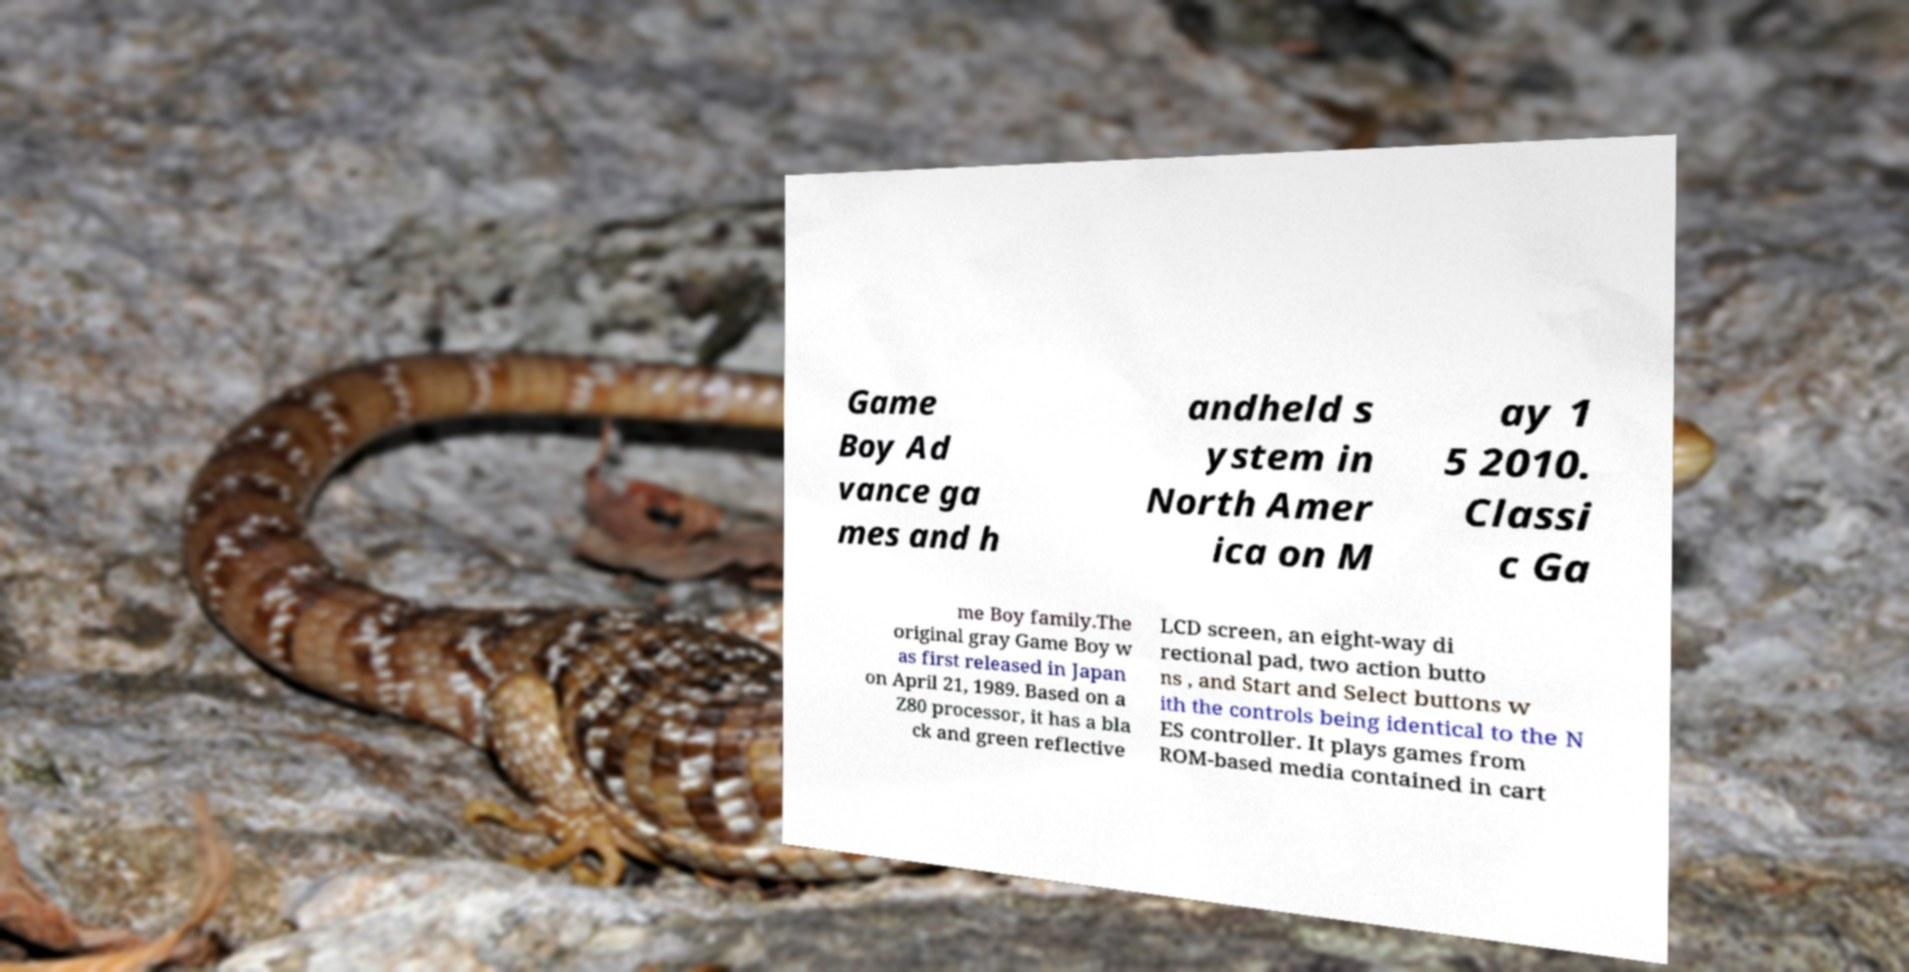For documentation purposes, I need the text within this image transcribed. Could you provide that? Game Boy Ad vance ga mes and h andheld s ystem in North Amer ica on M ay 1 5 2010. Classi c Ga me Boy family.The original gray Game Boy w as first released in Japan on April 21, 1989. Based on a Z80 processor, it has a bla ck and green reflective LCD screen, an eight-way di rectional pad, two action butto ns , and Start and Select buttons w ith the controls being identical to the N ES controller. It plays games from ROM-based media contained in cart 